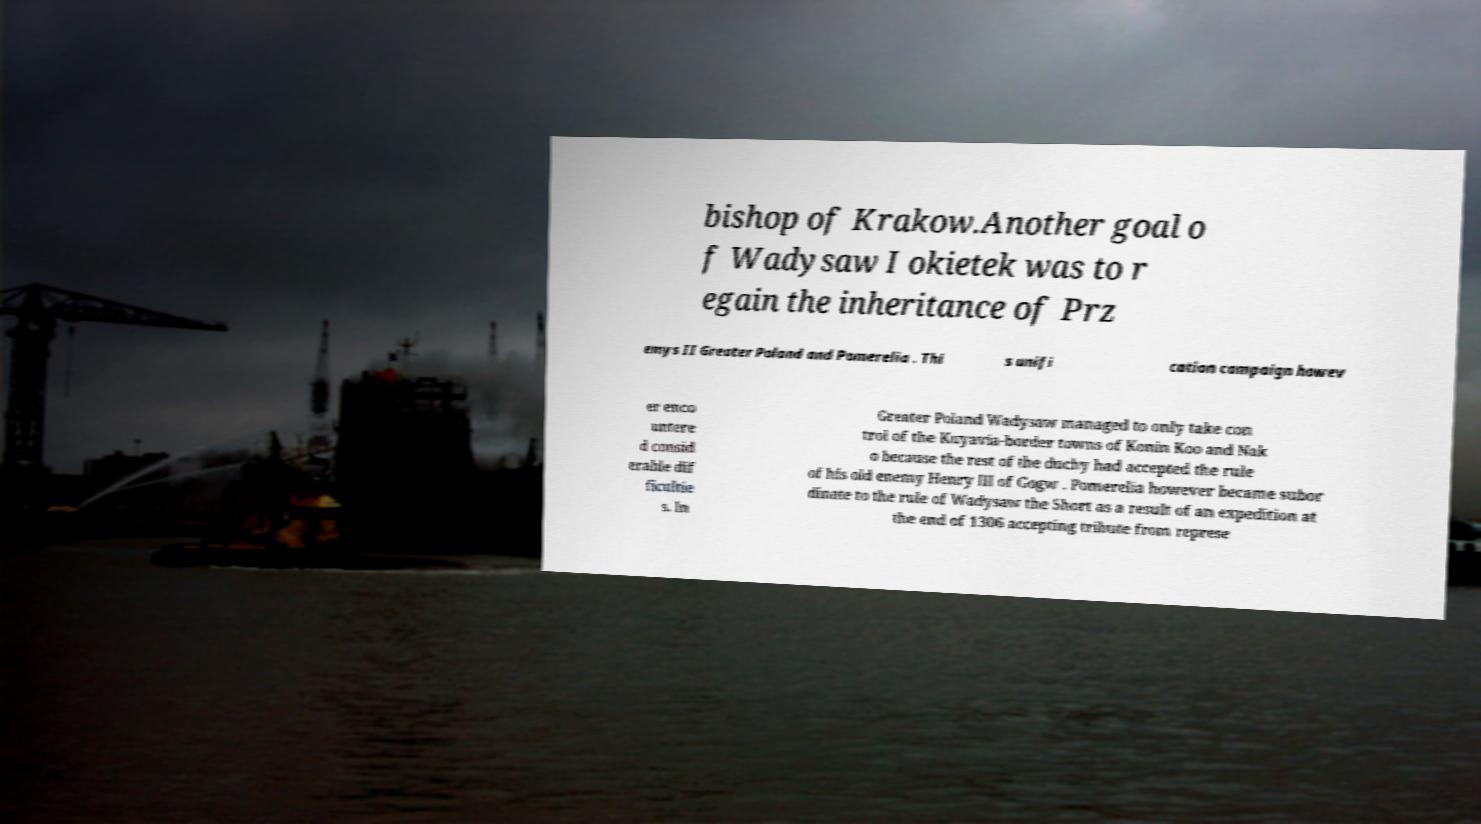Please read and relay the text visible in this image. What does it say? bishop of Krakow.Another goal o f Wadysaw I okietek was to r egain the inheritance of Prz emys II Greater Poland and Pomerelia . Thi s unifi cation campaign howev er enco untere d consid erable dif ficultie s. In Greater Poland Wadysaw managed to only take con trol of the Kuyavia-border towns of Konin Koo and Nak o because the rest of the duchy had accepted the rule of his old enemy Henry III of Gogw . Pomerelia however became subor dinate to the rule of Wadysaw the Short as a result of an expedition at the end of 1306 accepting tribute from represe 